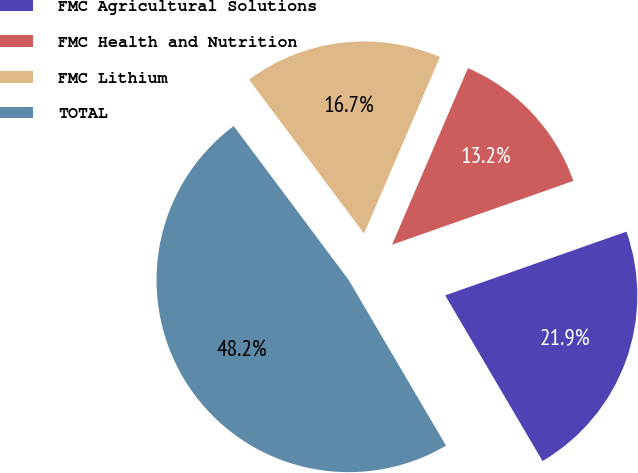<chart> <loc_0><loc_0><loc_500><loc_500><pie_chart><fcel>FMC Agricultural Solutions<fcel>FMC Health and Nutrition<fcel>FMC Lithium<fcel>TOTAL<nl><fcel>21.93%<fcel>13.16%<fcel>16.67%<fcel>48.25%<nl></chart> 